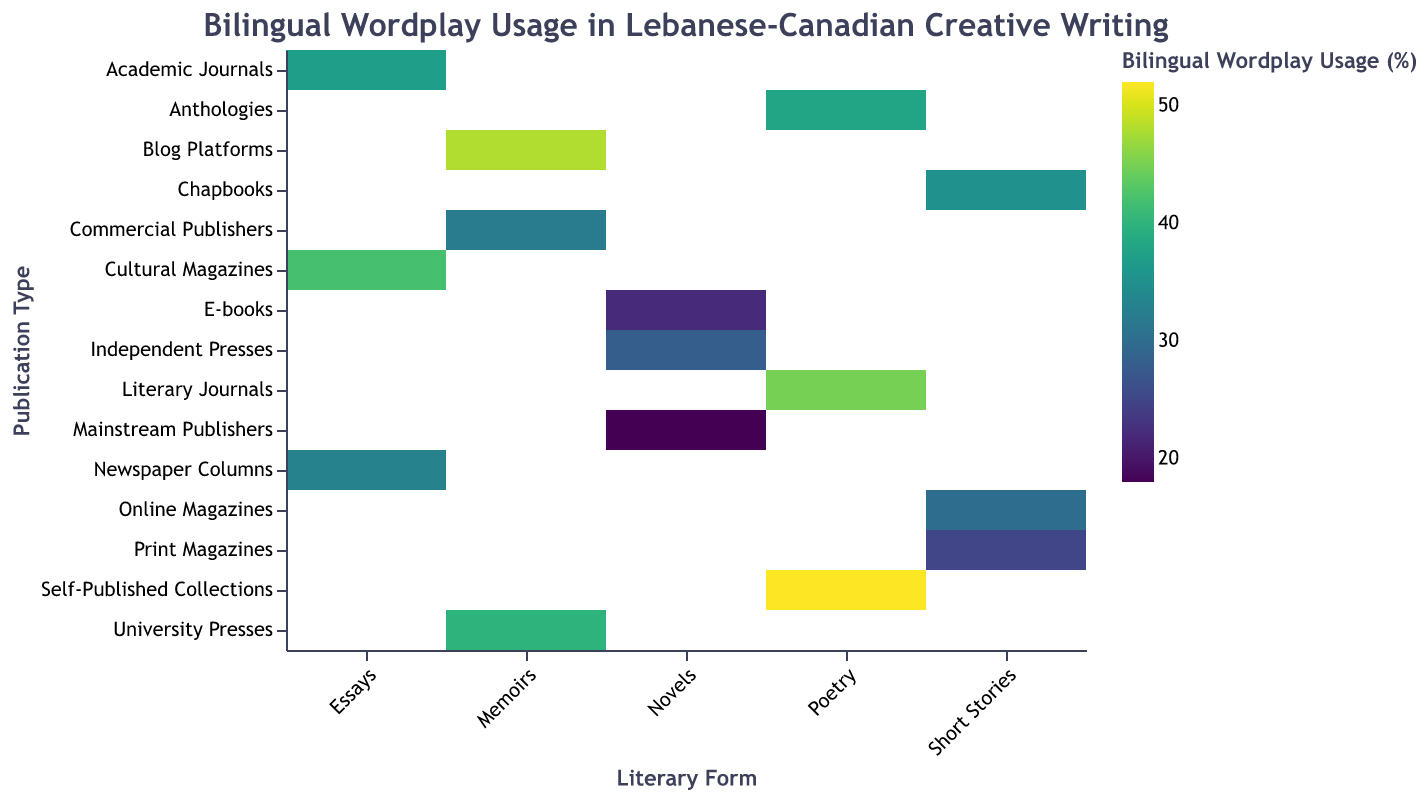What's the title of the figure? The title of the figure is displayed at the top.
Answer: Bilingual Wordplay Usage in Lebanese-Canadian Creative Writing What element is used to represent bilingual wordplay usage in the figure? The figure uses color intensity to represent bilingual wordplay usage percentages. Darker colors indicate higher usage.
Answer: Color Which literary form has the highest bilingual wordplay usage in self-published collections? Observing the "Poetry" row under the "Self-Published Collections" column, the usage percentage is the highest.
Answer: Poetry (52%) Which publication type shows the highest percentage of bilingual wordplay usage in Memoirs? In the "Memoirs" row, the "Blog Platforms" column shows the highest percentage.
Answer: Blog Platforms (48%) How does the usage of bilingual wordplay in anthologies compare between poetry and short stories? Comparing the "Poetry" row for "Anthologies" with the "Short Stories" row, we see that poetry usage is higher.
Answer: Poetry (38%) vs Short Stories (not applicable) What is the average bilingual wordplay usage across all forms published in literary journals? Add the values for literary journals (45 for Poetry) and divide by the number of literary forms represented in literary journals (1).
Answer: 45% Which literary form and publication type combination has the lowest bilingual wordplay usage? Looking at lighter colored areas, "Novels" and "Mainstream Publishers" have the lowest percentage.
Answer: Novels, Mainstream Publishers (18%) Is the bilingual wordplay usage higher in cultural magazines or newspaper columns for essays? Comparing the "Essays" row for "Cultural Magazines" (42%) and "Newspaper Columns" (33%), cultural magazines have higher usage.
Answer: Cultural Magazines What is the difference in bilingual wordplay usage between commercial publishers and university presses for memoirs? Subtract the percentage of "Commercial Publishers" (32%) from "University Presses" (40%). The difference is 8%.
Answer: 8% In which publication type is bilingual wordplay usage lowest for short stories? Observing the "Short Stories" row, "Print Magazines" have the lowest usage.
Answer: Print Magazines (25%) 